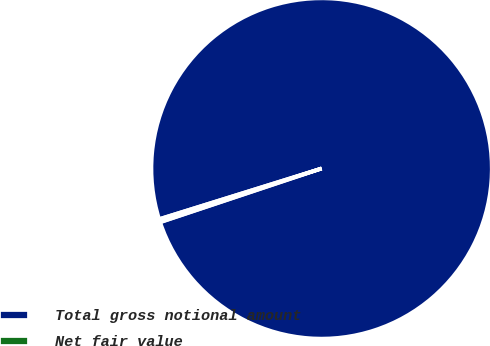Convert chart. <chart><loc_0><loc_0><loc_500><loc_500><pie_chart><fcel>Total gross notional amount<fcel>Net fair value<nl><fcel>99.69%<fcel>0.31%<nl></chart> 